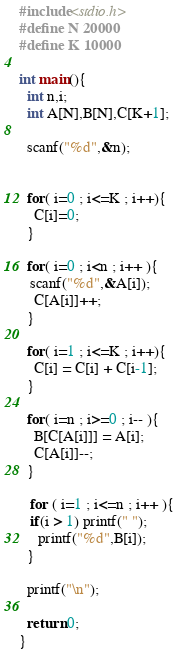<code> <loc_0><loc_0><loc_500><loc_500><_C_>#include<stdio.h>
#define N 20000
#define K 10000

int main(){
  int n,i;
  int A[N],B[N],C[K+1];

  scanf("%d",&n);


  for( i=0 ; i<=K ; i++){
    C[i]=0;
  }

  for( i=0 ; i<n ; i++ ){
   scanf("%d",&A[i]);
    C[A[i]]++;
  }

  for( i=1 ; i<=K ; i++){
    C[i] = C[i] + C[i-1];
  }

  for( i=n ; i>=0 ; i-- ){
    B[C[A[i]]] = A[i];
    C[A[i]]--;
  }
 
   for ( i=1 ; i<=n ; i++ ){
   if(i > 1) printf(" ");
     printf("%d",B[i]);
  }

  printf("\n");

  return 0;
} </code> 